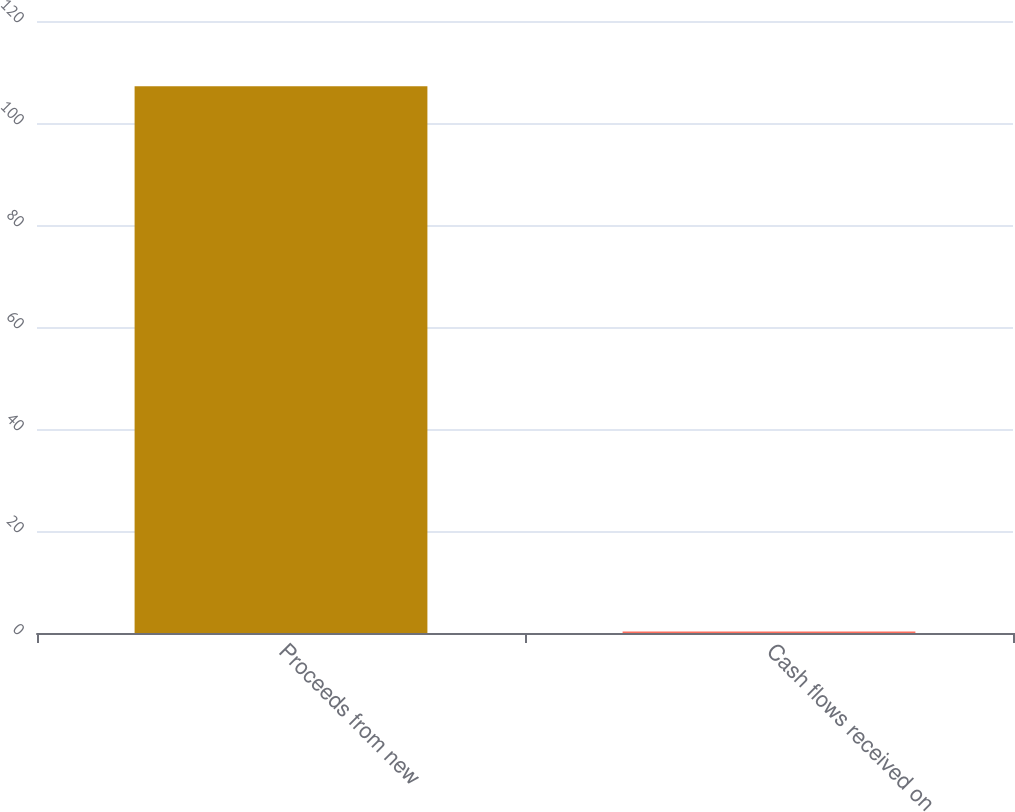Convert chart. <chart><loc_0><loc_0><loc_500><loc_500><bar_chart><fcel>Proceeds from new<fcel>Cash flows received on<nl><fcel>107.2<fcel>0.3<nl></chart> 